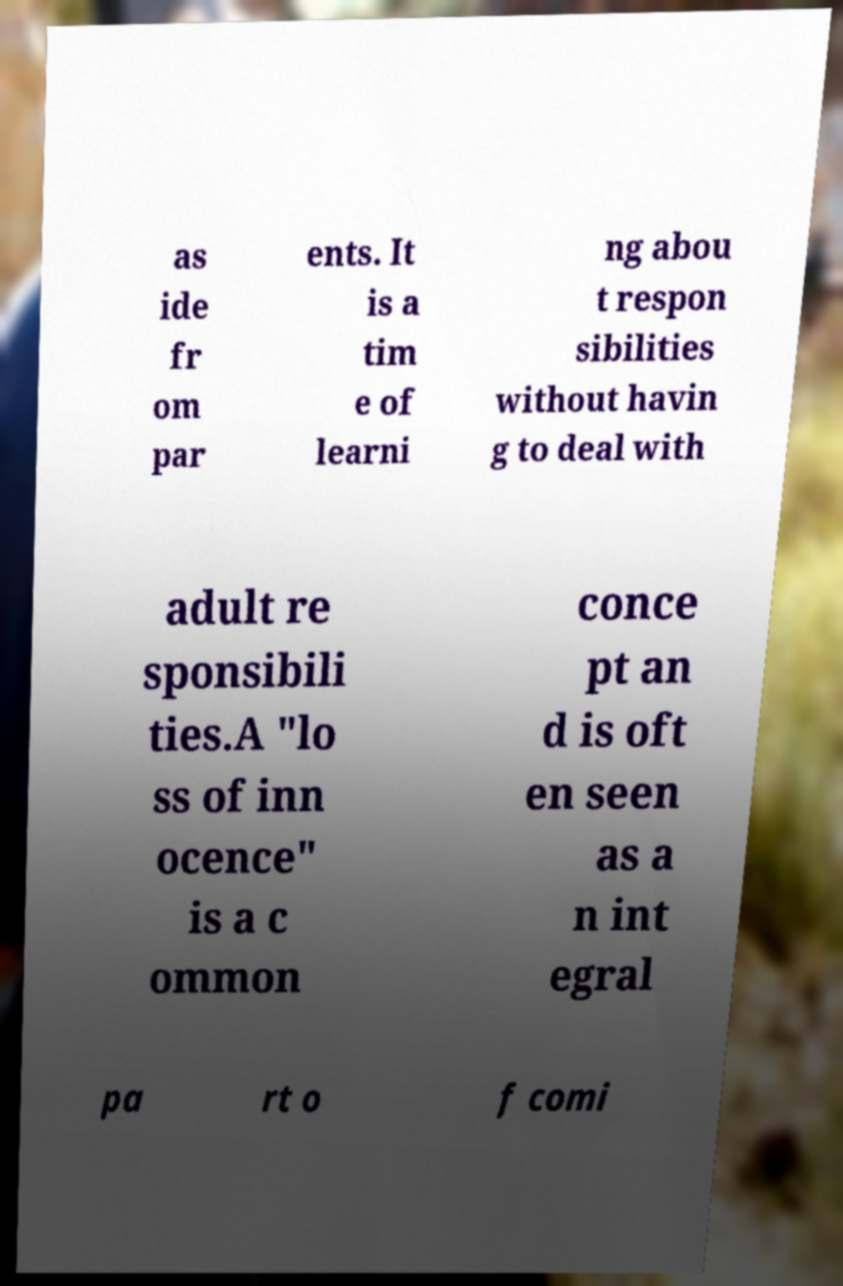Could you extract and type out the text from this image? as ide fr om par ents. It is a tim e of learni ng abou t respon sibilities without havin g to deal with adult re sponsibili ties.A "lo ss of inn ocence" is a c ommon conce pt an d is oft en seen as a n int egral pa rt o f comi 